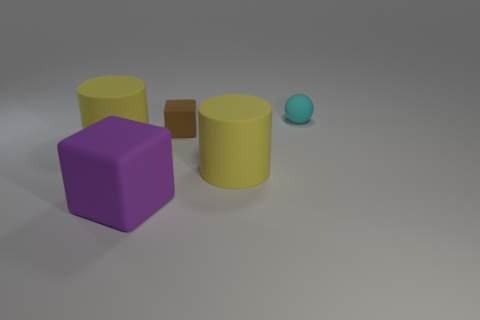What number of small objects are either purple blocks or brown rubber cubes?
Provide a short and direct response. 1. There is a matte object that is to the right of the large yellow rubber object that is on the right side of the small thing that is to the left of the tiny cyan thing; how big is it?
Your answer should be compact. Small. Is there anything else that is the same color as the small rubber block?
Offer a terse response. No. The tiny thing in front of the tiny rubber ball behind the small brown cube behind the purple thing is made of what material?
Provide a succinct answer. Rubber. Is the shape of the cyan rubber thing the same as the small brown rubber object?
Provide a succinct answer. No. Are there any other things that are made of the same material as the small cube?
Give a very brief answer. Yes. What number of rubber objects are both in front of the tiny brown block and to the right of the brown object?
Ensure brevity in your answer.  1. There is a matte cylinder on the left side of the tiny rubber object on the left side of the small ball; what is its color?
Keep it short and to the point. Yellow. Is the number of brown cubes that are behind the small brown rubber block the same as the number of tiny green cylinders?
Ensure brevity in your answer.  Yes. There is a matte cylinder behind the yellow rubber object that is on the right side of the purple block; how many cubes are right of it?
Your response must be concise. 2. 